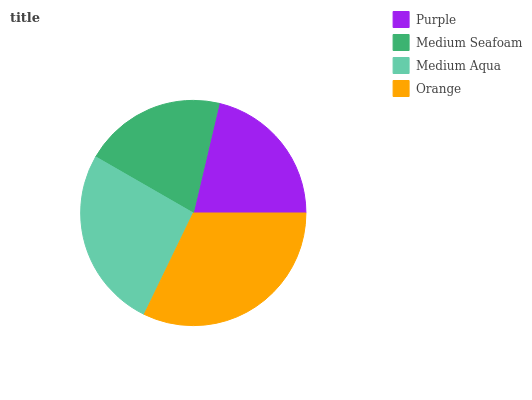Is Medium Seafoam the minimum?
Answer yes or no. Yes. Is Orange the maximum?
Answer yes or no. Yes. Is Medium Aqua the minimum?
Answer yes or no. No. Is Medium Aqua the maximum?
Answer yes or no. No. Is Medium Aqua greater than Medium Seafoam?
Answer yes or no. Yes. Is Medium Seafoam less than Medium Aqua?
Answer yes or no. Yes. Is Medium Seafoam greater than Medium Aqua?
Answer yes or no. No. Is Medium Aqua less than Medium Seafoam?
Answer yes or no. No. Is Medium Aqua the high median?
Answer yes or no. Yes. Is Purple the low median?
Answer yes or no. Yes. Is Purple the high median?
Answer yes or no. No. Is Medium Seafoam the low median?
Answer yes or no. No. 